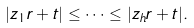Convert formula to latex. <formula><loc_0><loc_0><loc_500><loc_500>| z _ { 1 } r + t | \leq \dots \leq | z _ { h } r + t | .</formula> 